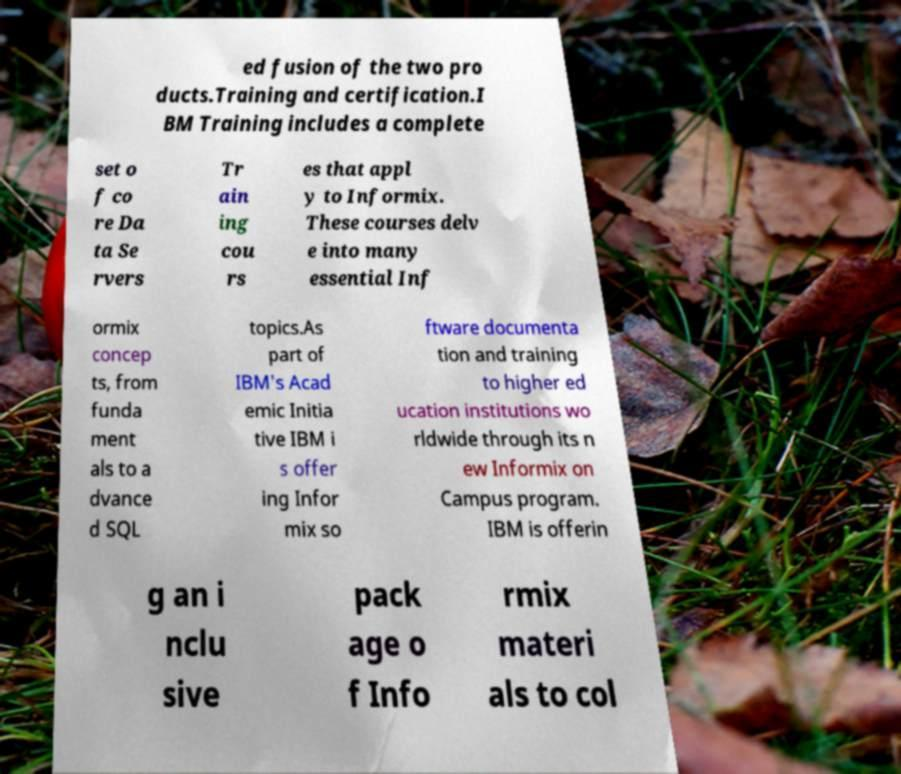I need the written content from this picture converted into text. Can you do that? ed fusion of the two pro ducts.Training and certification.I BM Training includes a complete set o f co re Da ta Se rvers Tr ain ing cou rs es that appl y to Informix. These courses delv e into many essential Inf ormix concep ts, from funda ment als to a dvance d SQL topics.As part of IBM's Acad emic Initia tive IBM i s offer ing Infor mix so ftware documenta tion and training to higher ed ucation institutions wo rldwide through its n ew Informix on Campus program. IBM is offerin g an i nclu sive pack age o f Info rmix materi als to col 